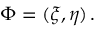Convert formula to latex. <formula><loc_0><loc_0><loc_500><loc_500>\boldsymbol \Phi = ( \xi , \eta ) \, .</formula> 